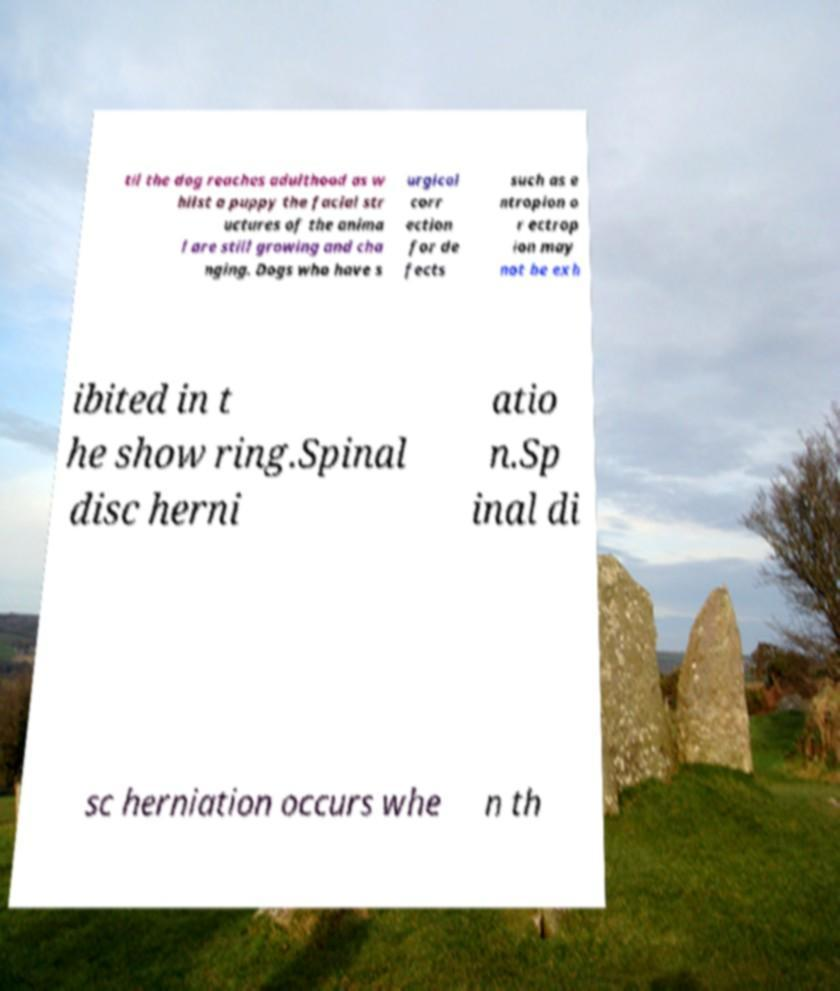Could you assist in decoding the text presented in this image and type it out clearly? til the dog reaches adulthood as w hilst a puppy the facial str uctures of the anima l are still growing and cha nging. Dogs who have s urgical corr ection for de fects such as e ntropion o r ectrop ion may not be exh ibited in t he show ring.Spinal disc herni atio n.Sp inal di sc herniation occurs whe n th 